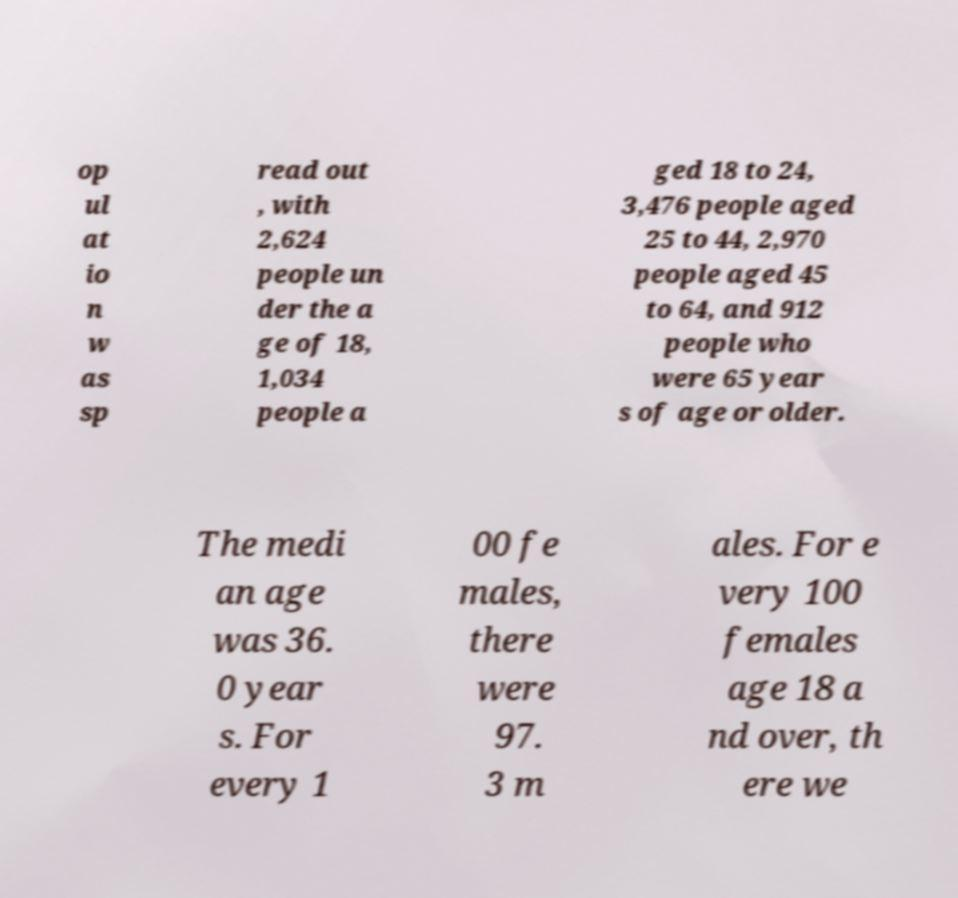There's text embedded in this image that I need extracted. Can you transcribe it verbatim? op ul at io n w as sp read out , with 2,624 people un der the a ge of 18, 1,034 people a ged 18 to 24, 3,476 people aged 25 to 44, 2,970 people aged 45 to 64, and 912 people who were 65 year s of age or older. The medi an age was 36. 0 year s. For every 1 00 fe males, there were 97. 3 m ales. For e very 100 females age 18 a nd over, th ere we 